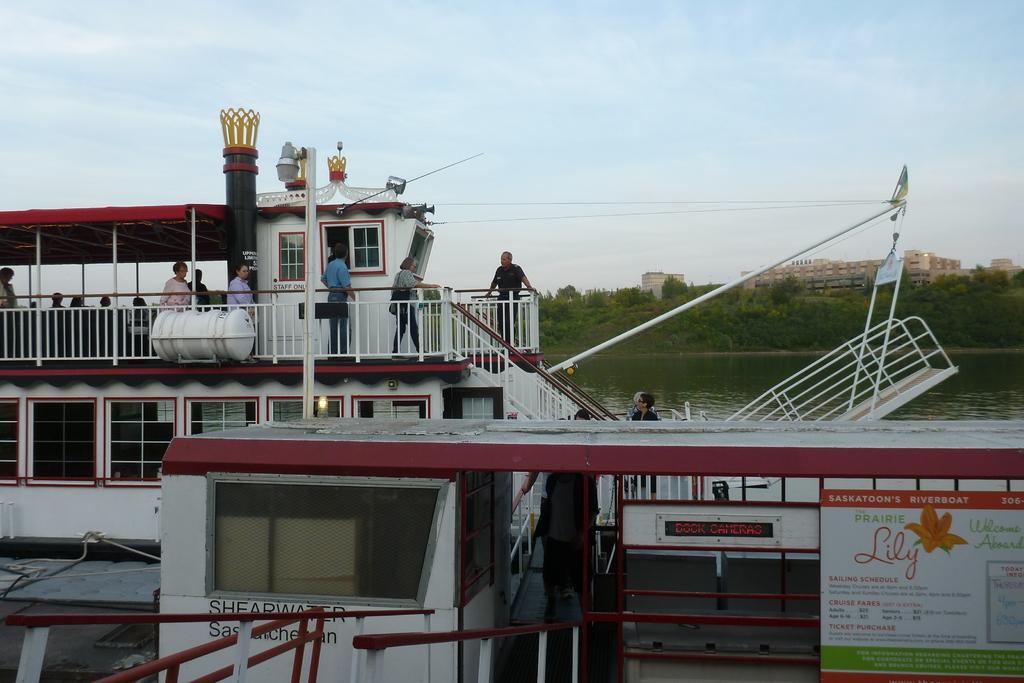Please provide a concise description of this image. There is a ship which has stairs, fencing and few people are present on it. At the back there is water, trees and buildings. 